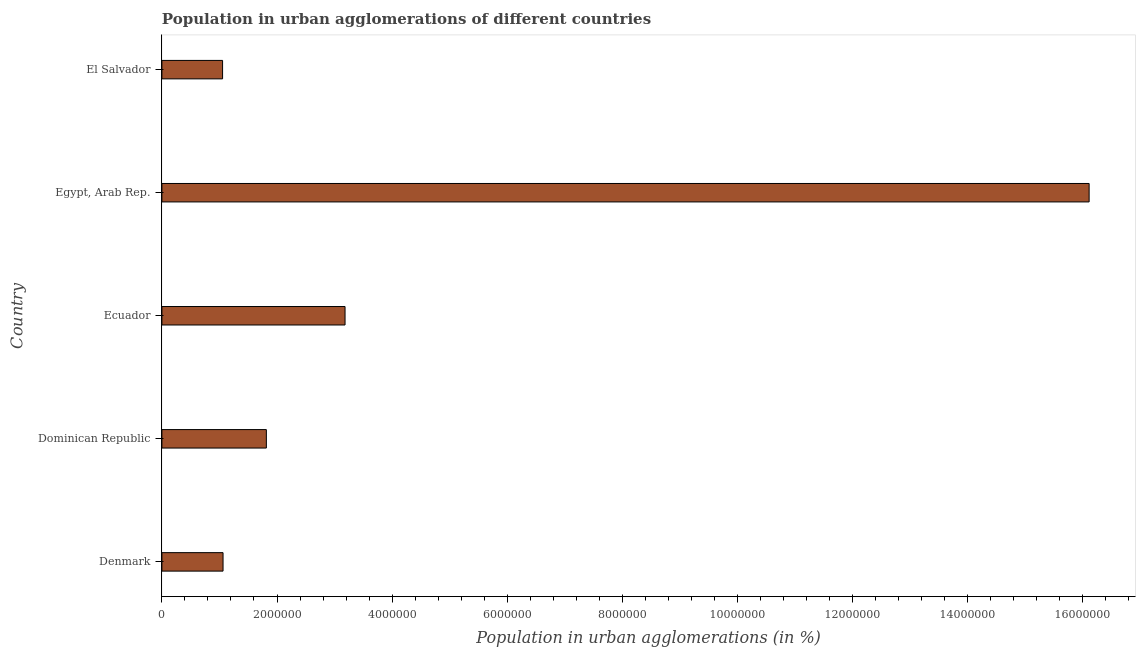Does the graph contain grids?
Offer a terse response. No. What is the title of the graph?
Your response must be concise. Population in urban agglomerations of different countries. What is the label or title of the X-axis?
Keep it short and to the point. Population in urban agglomerations (in %). What is the population in urban agglomerations in El Salvador?
Make the answer very short. 1.05e+06. Across all countries, what is the maximum population in urban agglomerations?
Provide a succinct answer. 1.61e+07. Across all countries, what is the minimum population in urban agglomerations?
Give a very brief answer. 1.05e+06. In which country was the population in urban agglomerations maximum?
Provide a succinct answer. Egypt, Arab Rep. In which country was the population in urban agglomerations minimum?
Offer a very short reply. El Salvador. What is the sum of the population in urban agglomerations?
Your response must be concise. 2.32e+07. What is the difference between the population in urban agglomerations in Denmark and Dominican Republic?
Offer a terse response. -7.53e+05. What is the average population in urban agglomerations per country?
Offer a terse response. 4.65e+06. What is the median population in urban agglomerations?
Ensure brevity in your answer.  1.81e+06. Is the population in urban agglomerations in Denmark less than that in Dominican Republic?
Keep it short and to the point. Yes. What is the difference between the highest and the second highest population in urban agglomerations?
Ensure brevity in your answer.  1.29e+07. What is the difference between the highest and the lowest population in urban agglomerations?
Give a very brief answer. 1.51e+07. In how many countries, is the population in urban agglomerations greater than the average population in urban agglomerations taken over all countries?
Give a very brief answer. 1. How many countries are there in the graph?
Offer a very short reply. 5. What is the difference between two consecutive major ticks on the X-axis?
Make the answer very short. 2.00e+06. Are the values on the major ticks of X-axis written in scientific E-notation?
Offer a very short reply. No. What is the Population in urban agglomerations (in %) of Denmark?
Your answer should be compact. 1.06e+06. What is the Population in urban agglomerations (in %) in Dominican Republic?
Offer a very short reply. 1.81e+06. What is the Population in urban agglomerations (in %) of Ecuador?
Keep it short and to the point. 3.18e+06. What is the Population in urban agglomerations (in %) in Egypt, Arab Rep.?
Offer a very short reply. 1.61e+07. What is the Population in urban agglomerations (in %) in El Salvador?
Ensure brevity in your answer.  1.05e+06. What is the difference between the Population in urban agglomerations (in %) in Denmark and Dominican Republic?
Offer a terse response. -7.53e+05. What is the difference between the Population in urban agglomerations (in %) in Denmark and Ecuador?
Give a very brief answer. -2.12e+06. What is the difference between the Population in urban agglomerations (in %) in Denmark and Egypt, Arab Rep.?
Offer a terse response. -1.50e+07. What is the difference between the Population in urban agglomerations (in %) in Denmark and El Salvador?
Give a very brief answer. 8061. What is the difference between the Population in urban agglomerations (in %) in Dominican Republic and Ecuador?
Keep it short and to the point. -1.37e+06. What is the difference between the Population in urban agglomerations (in %) in Dominican Republic and Egypt, Arab Rep.?
Your answer should be very brief. -1.43e+07. What is the difference between the Population in urban agglomerations (in %) in Dominican Republic and El Salvador?
Provide a succinct answer. 7.61e+05. What is the difference between the Population in urban agglomerations (in %) in Ecuador and Egypt, Arab Rep.?
Provide a short and direct response. -1.29e+07. What is the difference between the Population in urban agglomerations (in %) in Ecuador and El Salvador?
Offer a terse response. 2.13e+06. What is the difference between the Population in urban agglomerations (in %) in Egypt, Arab Rep. and El Salvador?
Ensure brevity in your answer.  1.51e+07. What is the ratio of the Population in urban agglomerations (in %) in Denmark to that in Dominican Republic?
Offer a very short reply. 0.58. What is the ratio of the Population in urban agglomerations (in %) in Denmark to that in Ecuador?
Your answer should be compact. 0.33. What is the ratio of the Population in urban agglomerations (in %) in Denmark to that in Egypt, Arab Rep.?
Your response must be concise. 0.07. What is the ratio of the Population in urban agglomerations (in %) in Dominican Republic to that in Ecuador?
Your response must be concise. 0.57. What is the ratio of the Population in urban agglomerations (in %) in Dominican Republic to that in Egypt, Arab Rep.?
Keep it short and to the point. 0.11. What is the ratio of the Population in urban agglomerations (in %) in Dominican Republic to that in El Salvador?
Keep it short and to the point. 1.72. What is the ratio of the Population in urban agglomerations (in %) in Ecuador to that in Egypt, Arab Rep.?
Make the answer very short. 0.2. What is the ratio of the Population in urban agglomerations (in %) in Ecuador to that in El Salvador?
Offer a very short reply. 3.02. What is the ratio of the Population in urban agglomerations (in %) in Egypt, Arab Rep. to that in El Salvador?
Offer a terse response. 15.28. 